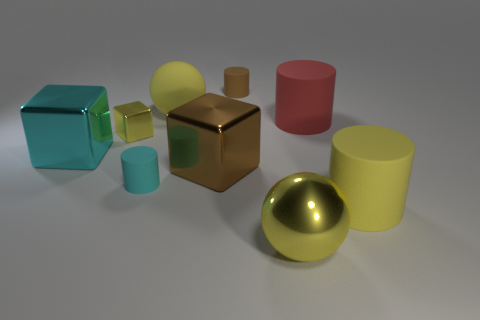Can you tell me what materials the objects in the image appear to be made of? The objects in the image seem to be made of various materials. The slightly reflective surfaces suggest that some could be metallic, like the golden sphere and the copper cube. Others appear to be made of a matte substance, potentially plastic, such as the various cylinders and cubes in red, yellow, blue, and aqua colors. 